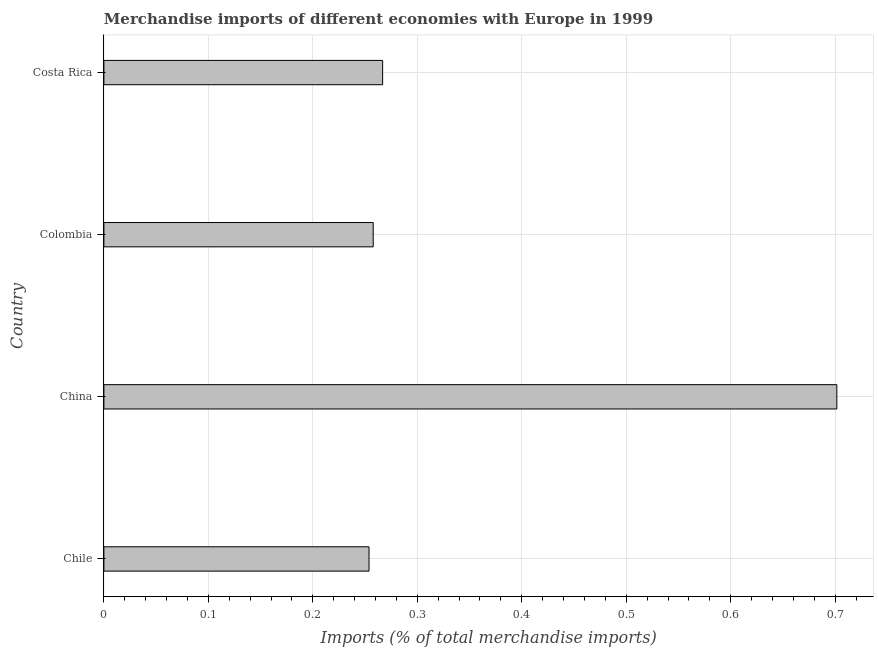Does the graph contain any zero values?
Make the answer very short. No. What is the title of the graph?
Your answer should be compact. Merchandise imports of different economies with Europe in 1999. What is the label or title of the X-axis?
Make the answer very short. Imports (% of total merchandise imports). What is the merchandise imports in Colombia?
Your answer should be very brief. 0.26. Across all countries, what is the maximum merchandise imports?
Provide a succinct answer. 0.7. Across all countries, what is the minimum merchandise imports?
Your answer should be compact. 0.25. In which country was the merchandise imports minimum?
Offer a terse response. Chile. What is the sum of the merchandise imports?
Give a very brief answer. 1.48. What is the difference between the merchandise imports in Chile and Colombia?
Your answer should be compact. -0. What is the average merchandise imports per country?
Ensure brevity in your answer.  0.37. What is the median merchandise imports?
Make the answer very short. 0.26. In how many countries, is the merchandise imports greater than 0.56 %?
Give a very brief answer. 1. Is the difference between the merchandise imports in China and Costa Rica greater than the difference between any two countries?
Your response must be concise. No. What is the difference between the highest and the second highest merchandise imports?
Keep it short and to the point. 0.43. Is the sum of the merchandise imports in Chile and Costa Rica greater than the maximum merchandise imports across all countries?
Ensure brevity in your answer.  No. What is the difference between the highest and the lowest merchandise imports?
Ensure brevity in your answer.  0.45. How many bars are there?
Keep it short and to the point. 4. Are all the bars in the graph horizontal?
Your answer should be very brief. Yes. How many countries are there in the graph?
Offer a terse response. 4. Are the values on the major ticks of X-axis written in scientific E-notation?
Provide a succinct answer. No. What is the Imports (% of total merchandise imports) in Chile?
Your answer should be very brief. 0.25. What is the Imports (% of total merchandise imports) of China?
Your answer should be compact. 0.7. What is the Imports (% of total merchandise imports) in Colombia?
Your answer should be compact. 0.26. What is the Imports (% of total merchandise imports) in Costa Rica?
Make the answer very short. 0.27. What is the difference between the Imports (% of total merchandise imports) in Chile and China?
Your answer should be very brief. -0.45. What is the difference between the Imports (% of total merchandise imports) in Chile and Colombia?
Provide a succinct answer. -0. What is the difference between the Imports (% of total merchandise imports) in Chile and Costa Rica?
Provide a succinct answer. -0.01. What is the difference between the Imports (% of total merchandise imports) in China and Colombia?
Give a very brief answer. 0.44. What is the difference between the Imports (% of total merchandise imports) in China and Costa Rica?
Offer a very short reply. 0.43. What is the difference between the Imports (% of total merchandise imports) in Colombia and Costa Rica?
Ensure brevity in your answer.  -0.01. What is the ratio of the Imports (% of total merchandise imports) in Chile to that in China?
Your answer should be very brief. 0.36. What is the ratio of the Imports (% of total merchandise imports) in Chile to that in Colombia?
Provide a succinct answer. 0.98. What is the ratio of the Imports (% of total merchandise imports) in Chile to that in Costa Rica?
Keep it short and to the point. 0.95. What is the ratio of the Imports (% of total merchandise imports) in China to that in Colombia?
Offer a terse response. 2.72. What is the ratio of the Imports (% of total merchandise imports) in China to that in Costa Rica?
Offer a terse response. 2.63. 